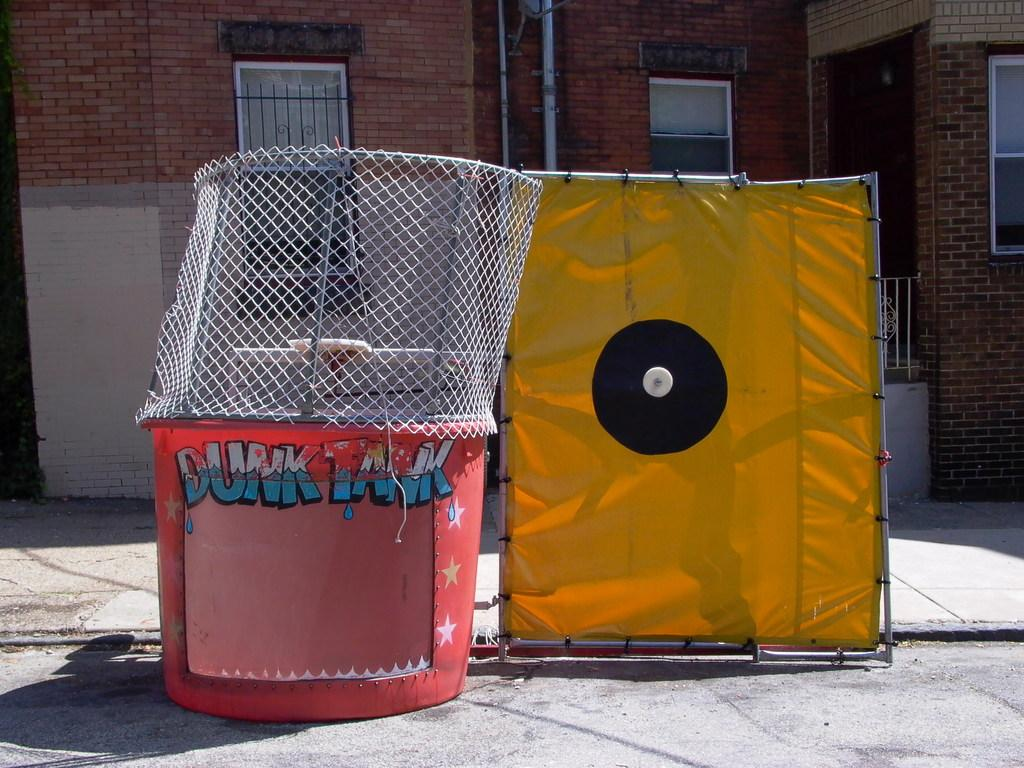<image>
Share a concise interpretation of the image provided. A red dunk tank kit that is not set up yet. 